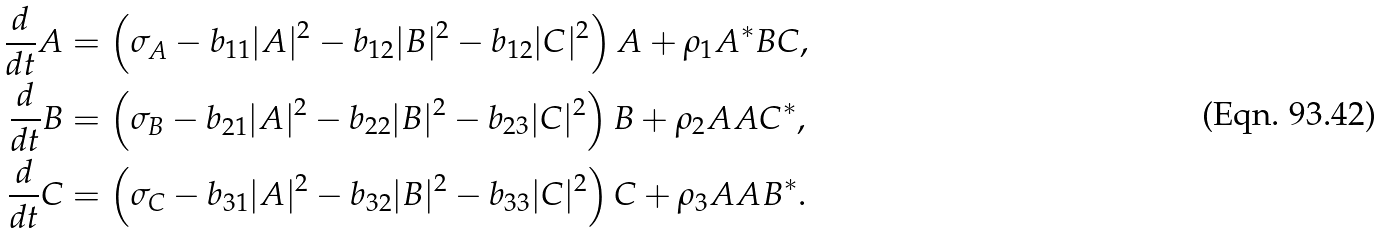Convert formula to latex. <formula><loc_0><loc_0><loc_500><loc_500>\frac { d } { d t } A & = \left ( \sigma _ { A } - b _ { 1 1 } | A | ^ { 2 } - b _ { 1 2 } | B | ^ { 2 } - b _ { 1 2 } | C | ^ { 2 } \right ) A + \rho _ { 1 } A ^ { * } B C , \\ \frac { d } { d t } B & = \left ( \sigma _ { B } - b _ { 2 1 } | A | ^ { 2 } - b _ { 2 2 } | B | ^ { 2 } - b _ { 2 3 } | C | ^ { 2 } \right ) B + \rho _ { 2 } A A C ^ { * } , \\ \frac { d } { d t } C & = \left ( \sigma _ { C } - b _ { 3 1 } | A | ^ { 2 } - b _ { 3 2 } | B | ^ { 2 } - b _ { 3 3 } | C | ^ { 2 } \right ) C + \rho _ { 3 } A A B ^ { * } .</formula> 